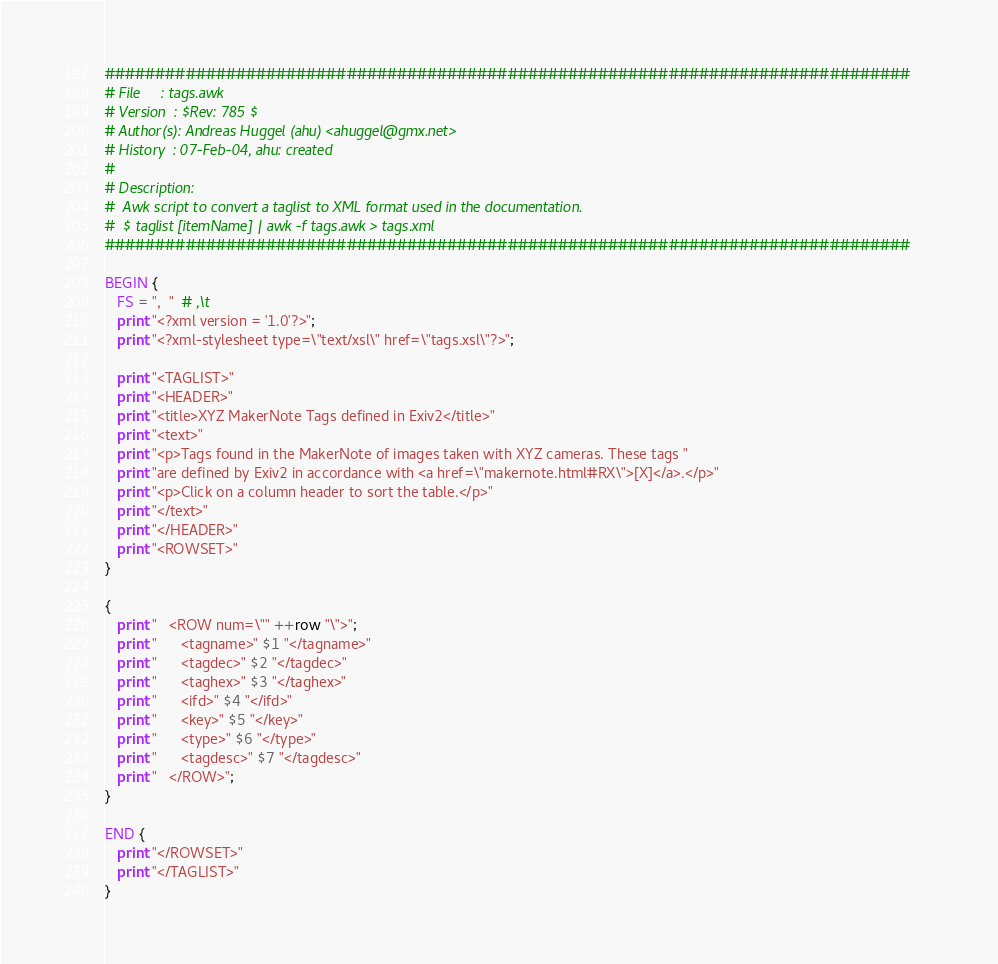<code> <loc_0><loc_0><loc_500><loc_500><_Awk_>################################################################################
# File     : tags.awk
# Version  : $Rev: 785 $
# Author(s): Andreas Huggel (ahu) <ahuggel@gmx.net>
# History  : 07-Feb-04, ahu: created
#
# Description:
#  Awk script to convert a taglist to XML format used in the documentation.
#  $ taglist [itemName] | awk -f tags.awk > tags.xml
################################################################################

BEGIN {
   FS = ",	"  # ,\t
   print "<?xml version = '1.0'?>";   
   print "<?xml-stylesheet type=\"text/xsl\" href=\"tags.xsl\"?>";

   print "<TAGLIST>"
   print "<HEADER>"
   print "<title>XYZ MakerNote Tags defined in Exiv2</title>"
   print "<text>"
   print "<p>Tags found in the MakerNote of images taken with XYZ cameras. These tags "
   print "are defined by Exiv2 in accordance with <a href=\"makernote.html#RX\">[X]</a>.</p>"
   print "<p>Click on a column header to sort the table.</p>"
   print "</text>"
   print "</HEADER>"
   print "<ROWSET>"
}

{
   print "   <ROW num=\"" ++row "\">";
   print "      <tagname>" $1 "</tagname>"
   print "      <tagdec>" $2 "</tagdec>"
   print "      <taghex>" $3 "</taghex>"
   print "      <ifd>" $4 "</ifd>"
   print "      <key>" $5 "</key>"
   print "      <type>" $6 "</type>"
   print "      <tagdesc>" $7 "</tagdesc>"
   print "   </ROW>";
}

END {
   print "</ROWSET>"   
   print "</TAGLIST>"
}
</code> 